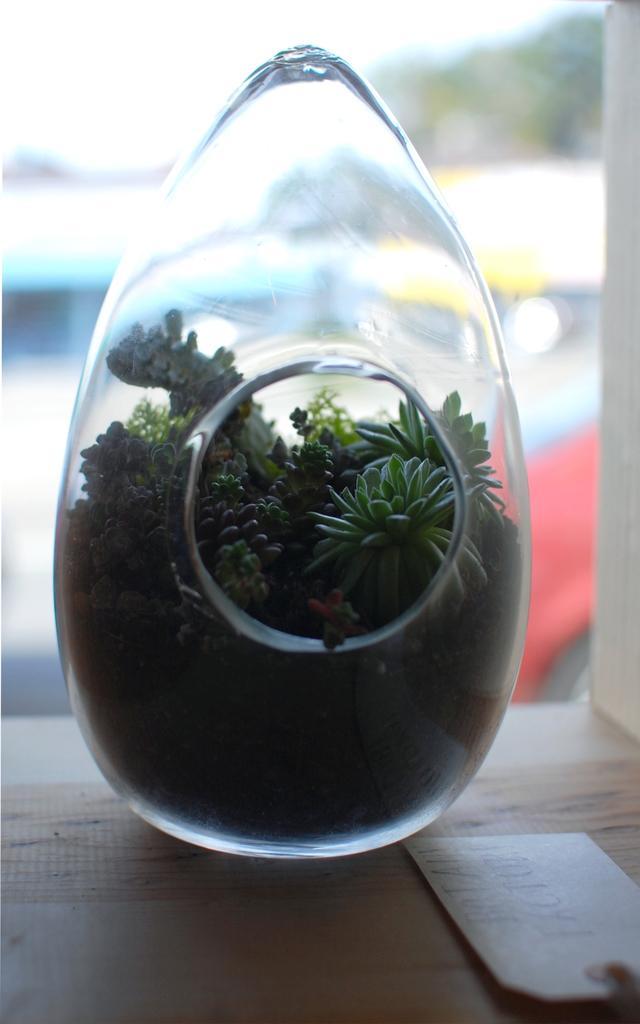How would you summarize this image in a sentence or two? In this image we can see a glass object on the surface. 